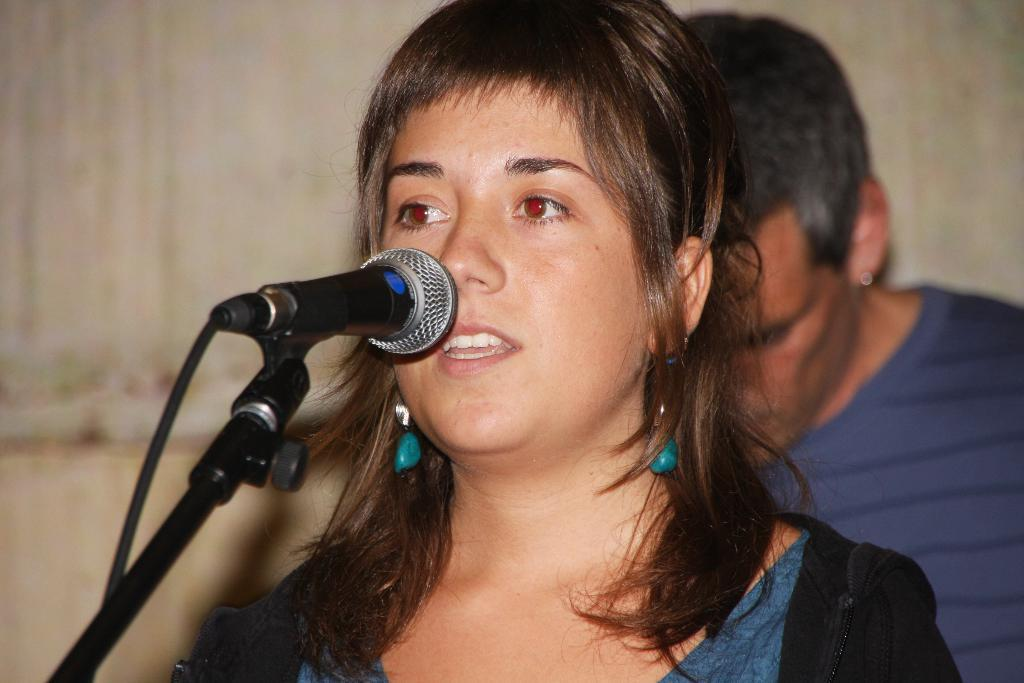What is the main subject of the image? There is a woman in the image. What is the woman doing in the image? The woman is standing and singing with the help of a microphone. Is there anyone else in the image? Yes, there is a man in the image. What is the man doing in the image? The man is standing on the back of the woman. What can be seen in the background of the image? There is a wall in the background of the image. How many geese are flying in the image? There are no geese present in the image. What type of lizards can be seen crawling on the wall in the image? There are no lizards present in the image; only a wall is visible in the background. 